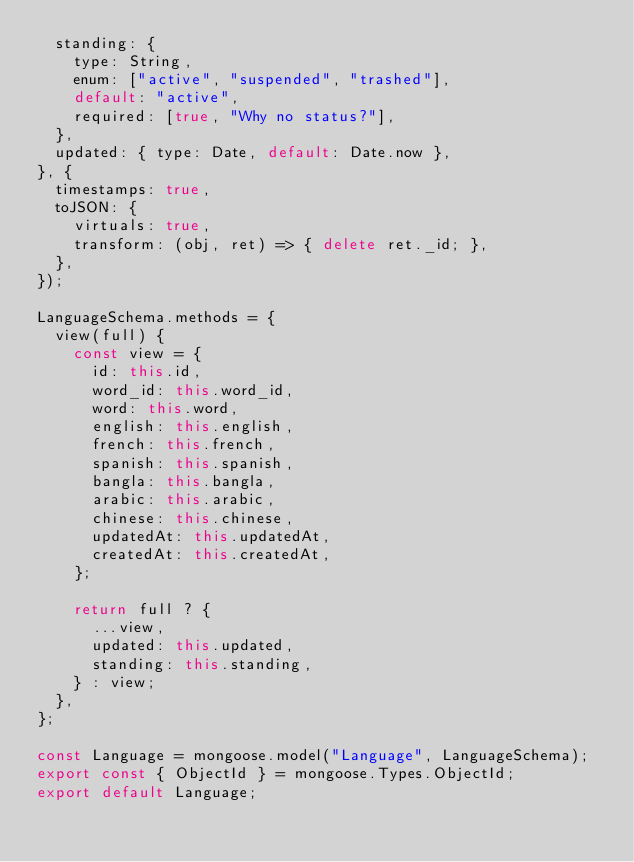Convert code to text. <code><loc_0><loc_0><loc_500><loc_500><_JavaScript_>  standing: {
    type: String,
    enum: ["active", "suspended", "trashed"],
    default: "active",
    required: [true, "Why no status?"],
  },
  updated: { type: Date, default: Date.now },
}, {
  timestamps: true,
  toJSON: {
    virtuals: true,
    transform: (obj, ret) => { delete ret._id; },
  },
});

LanguageSchema.methods = {
  view(full) {
    const view = {
      id: this.id,
      word_id: this.word_id,
      word: this.word,
      english: this.english,
      french: this.french,
      spanish: this.spanish,
      bangla: this.bangla,
      arabic: this.arabic,
      chinese: this.chinese,
      updatedAt: this.updatedAt,
      createdAt: this.createdAt,
    };

    return full ? {
      ...view,
      updated: this.updated,
      standing: this.standing,
    } : view;
  },
};

const Language = mongoose.model("Language", LanguageSchema);
export const { ObjectId } = mongoose.Types.ObjectId;
export default Language;
</code> 